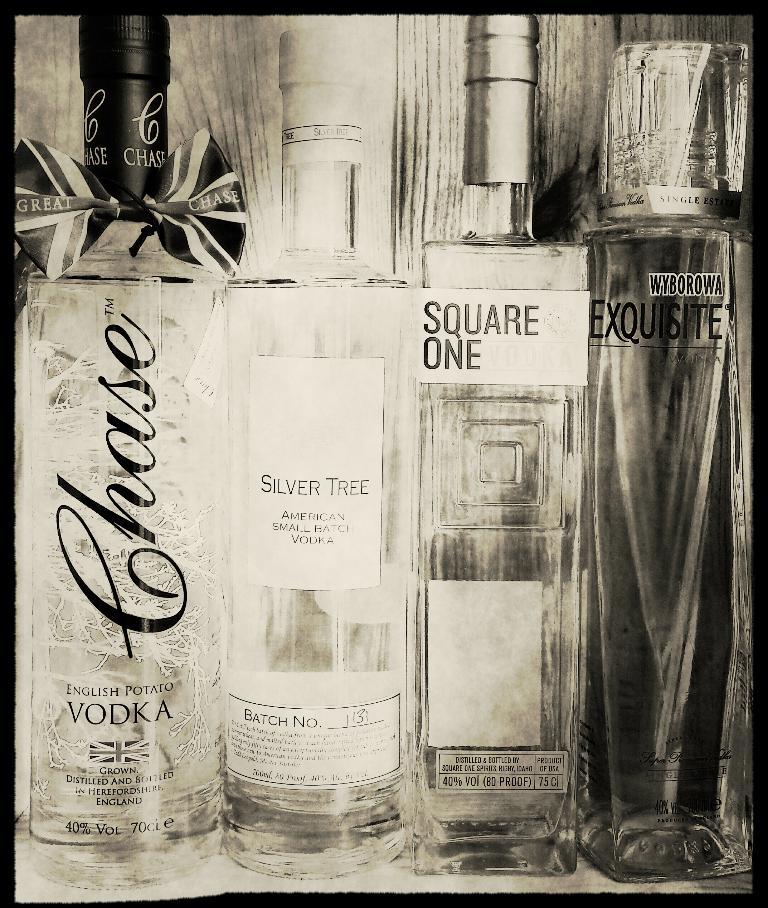What is the name of the second bottle?
Your response must be concise. Silver tree. 